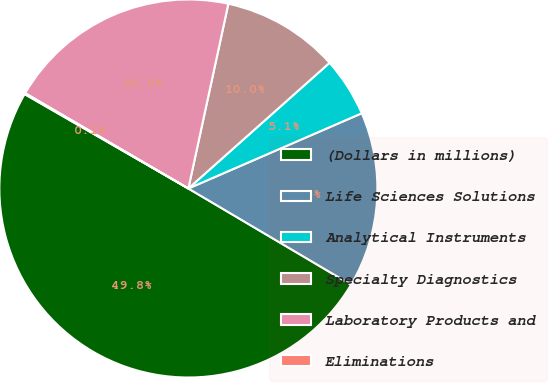<chart> <loc_0><loc_0><loc_500><loc_500><pie_chart><fcel>(Dollars in millions)<fcel>Life Sciences Solutions<fcel>Analytical Instruments<fcel>Specialty Diagnostics<fcel>Laboratory Products and<fcel>Eliminations<nl><fcel>49.83%<fcel>15.01%<fcel>5.06%<fcel>10.03%<fcel>19.98%<fcel>0.09%<nl></chart> 